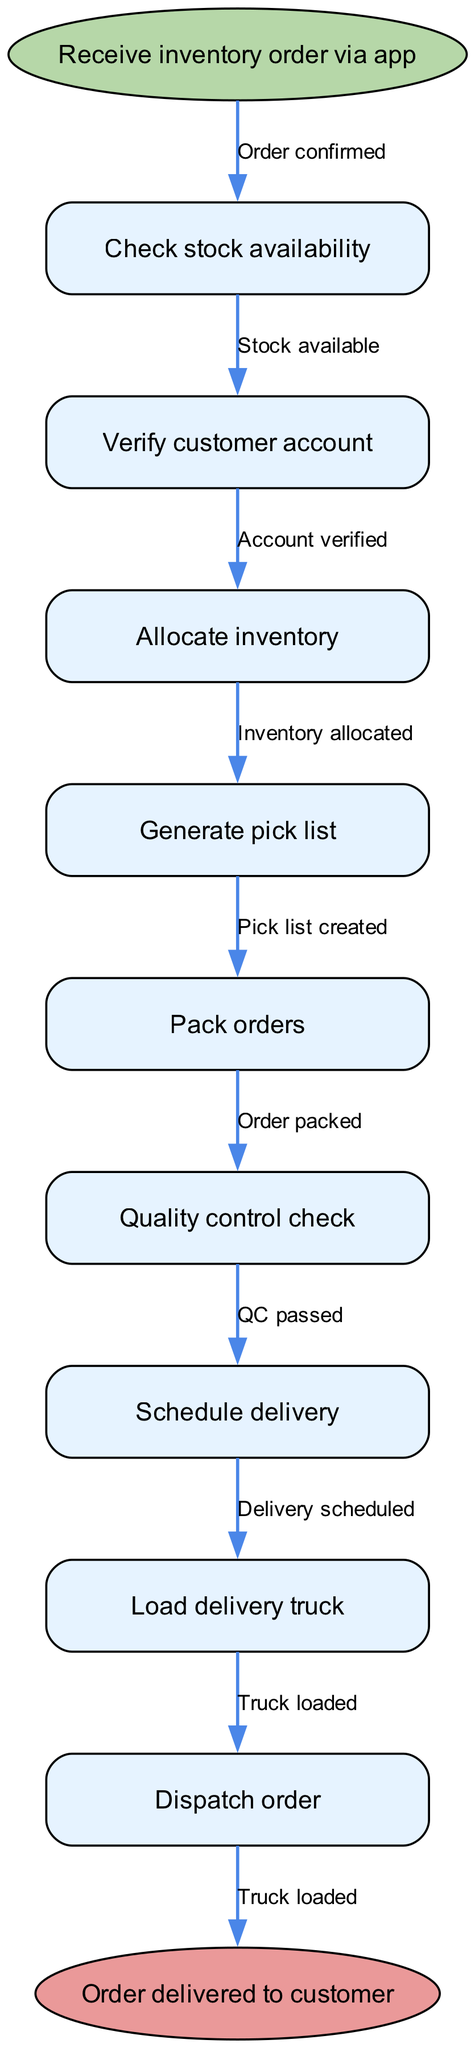What is the first step in the process? The first step is to "Receive inventory order via app," which is the starting node in the pathway diagram.
Answer: Receive inventory order via app How many nodes are present in the diagram? The diagram contains a total of nine nodes, including the start and end nodes.
Answer: Nine What happens after verifying the customer account? After verifying the customer account, the next step is to "Allocate inventory," which follows directly in the sequence.
Answer: Allocate inventory What is the last node in the process? The last node in the process is "Order delivered to customer," representing the completion of the pathway.
Answer: Order delivered to customer What indicates a successful quality control check? A successful quality control check is indicated by the edge labeled "QC passed," which connects the "Quality control check" node to the next step in the process.
Answer: QC passed How does the process proceed if stock is not available? If stock is not available, the process cannot proceed to the "Allocate inventory" node, as that step depends on stock being available. Instead, the pathway would terminate or loop to check stock again.
Answer: Process halts Which step occurs just before loading the delivery truck? The step that occurs just before loading the delivery truck is "Schedule delivery," which directly precedes the loading of the truck in the sequence.
Answer: Schedule delivery What connects the "Pack orders" and "Quality control check" nodes? The connection between the "Pack orders" and "Quality control check" nodes is through the edge labeled "Order packed," indicating successful packing before quality control is checked.
Answer: Order packed What is required for inventory allocation? Inventory allocation requires prior successful completion of "Check stock availability," as inventory must be available before it can be allocated.
Answer: Stock available 